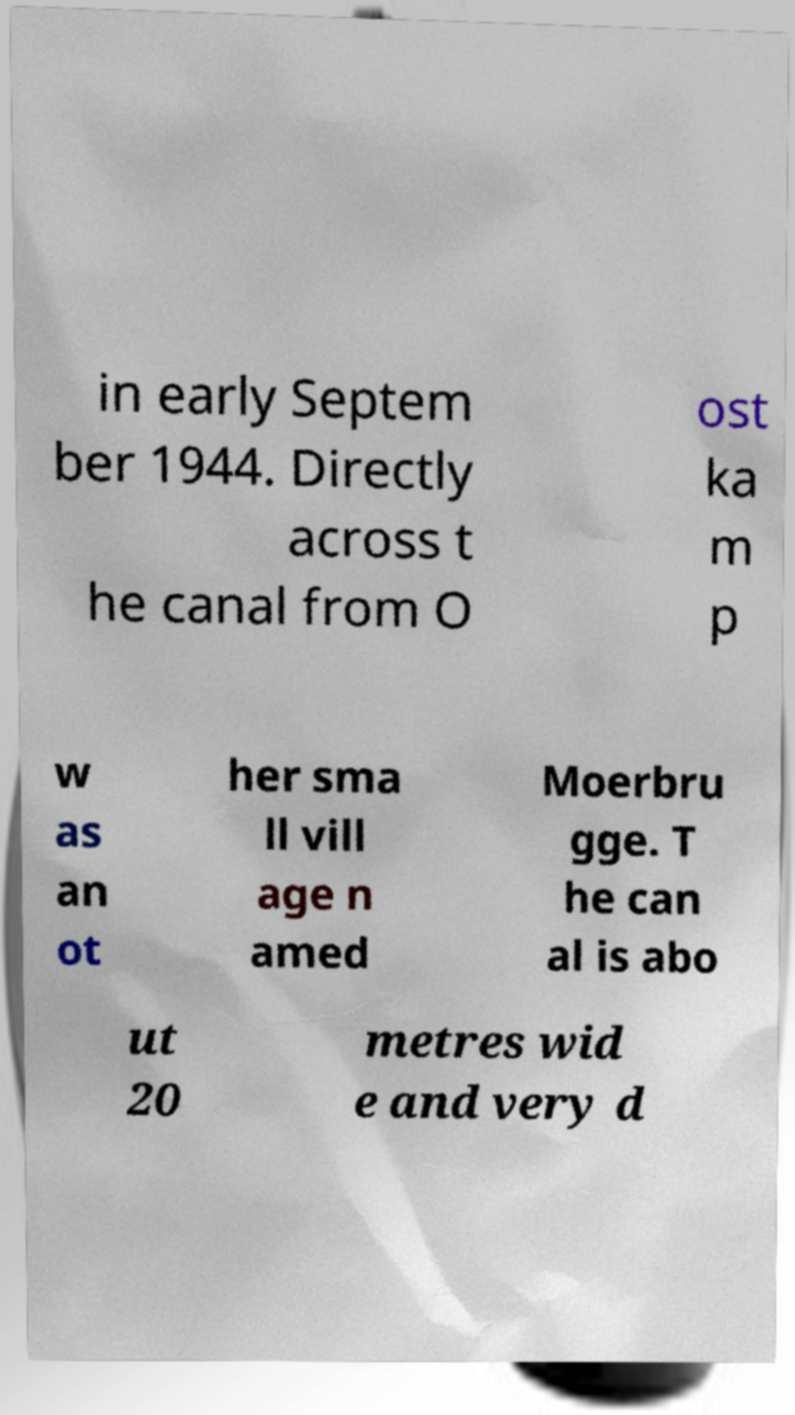Can you accurately transcribe the text from the provided image for me? in early Septem ber 1944. Directly across t he canal from O ost ka m p w as an ot her sma ll vill age n amed Moerbru gge. T he can al is abo ut 20 metres wid e and very d 